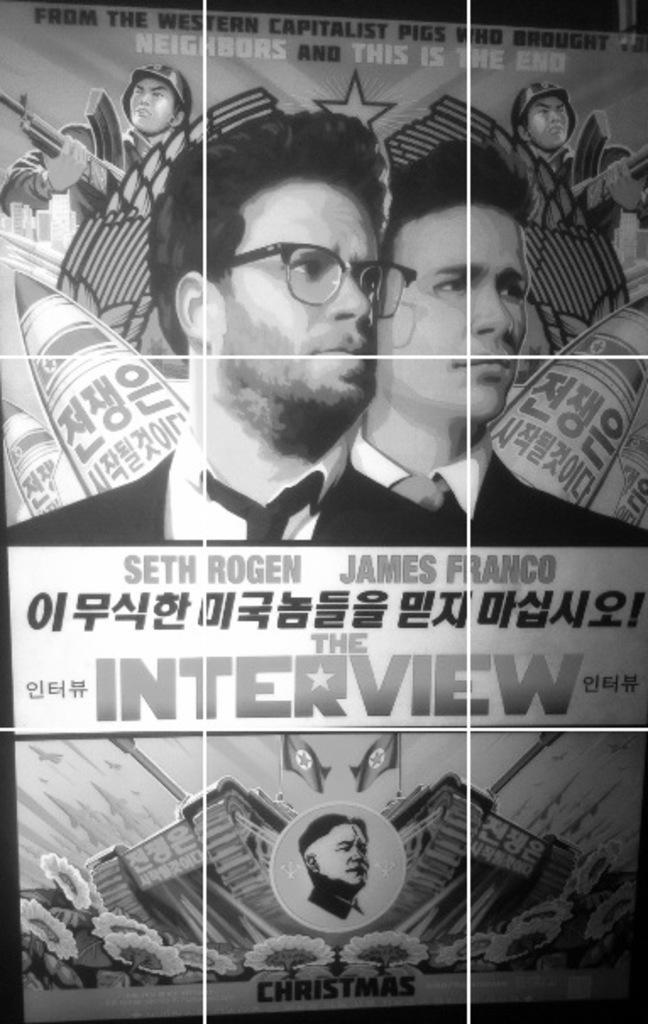Could you give a brief overview of what you see in this image? This is a black and white image. I can see a poster. There are two people. These are the buildings. I can see the flags. These are the trees. I can see the letters on the poster. 